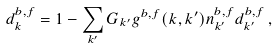Convert formula to latex. <formula><loc_0><loc_0><loc_500><loc_500>d _ { k } ^ { b , f } = 1 - \sum _ { k ^ { \prime } } G _ { k ^ { \prime } } g ^ { b , f } ( k , k ^ { \prime } ) n _ { k ^ { \prime } } ^ { b , f } d _ { k ^ { \prime } } ^ { b , f } \, ,</formula> 